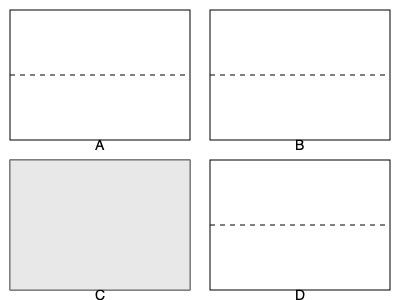You are comparing floor plans of four different apartments. Which apartment layout has the most balanced distribution of space between its upper and lower halves? To determine which apartment layout has the most balanced distribution of space between its upper and lower halves, we need to analyze each floor plan:

1. Apartment A: The upper and lower halves appear to be equal in size, separated by a dashed line in the middle.

2. Apartment B: Similar to A, the upper and lower halves are equal in size, divided by a dashed line.

3. Apartment C: This layout is divided into two vertical halves, each shaded differently. There is no horizontal division, indicating an uneven distribution between upper and lower halves.

4. Apartment D: The upper half is larger than the lower half, as shown by the dashed line being positioned below the center.

Apartments A and B both have equally divided upper and lower halves, making them the most balanced in terms of space distribution. However, since we need to choose one answer, we can consider Apartment A as it's the first one that meets the criteria.
Answer: Apartment A 